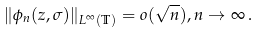Convert formula to latex. <formula><loc_0><loc_0><loc_500><loc_500>\| \phi _ { n } ( z , \sigma ) \| _ { L ^ { \infty } ( \mathbb { T } ) } = o ( \sqrt { n } ) , n \to \infty \, .</formula> 